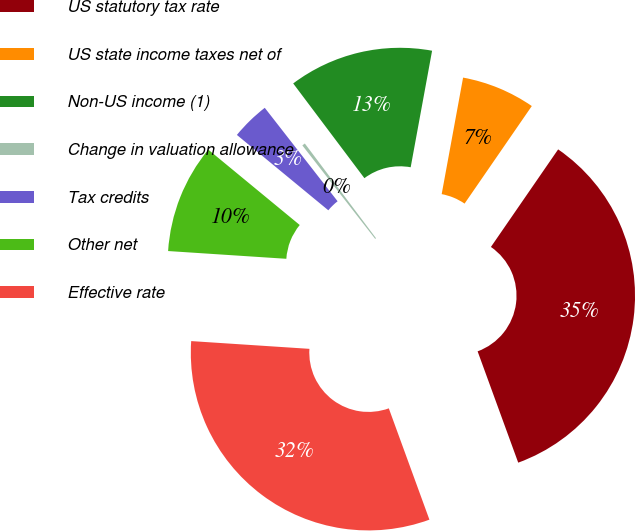Convert chart to OTSL. <chart><loc_0><loc_0><loc_500><loc_500><pie_chart><fcel>US statutory tax rate<fcel>US state income taxes net of<fcel>Non-US income (1)<fcel>Change in valuation allowance<fcel>Tax credits<fcel>Other net<fcel>Effective rate<nl><fcel>34.83%<fcel>6.71%<fcel>13.15%<fcel>0.28%<fcel>3.49%<fcel>9.93%<fcel>31.61%<nl></chart> 